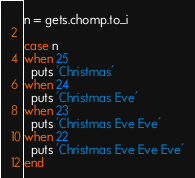Convert code to text. <code><loc_0><loc_0><loc_500><loc_500><_Ruby_>n = gets.chomp.to_i

case n
when 25
  puts 'Christmas'
when 24
  puts 'Christmas Eve'
when 23
  puts 'Christmas Eve Eve'
when 22
  puts 'Christmas Eve Eve Eve'
end
</code> 